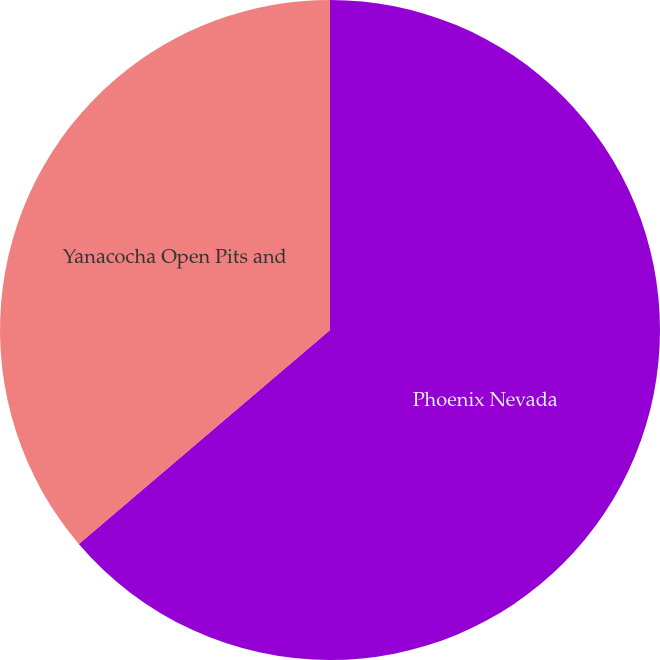<chart> <loc_0><loc_0><loc_500><loc_500><pie_chart><fcel>Phoenix Nevada<fcel>Yanacocha Open Pits and<nl><fcel>63.77%<fcel>36.23%<nl></chart> 